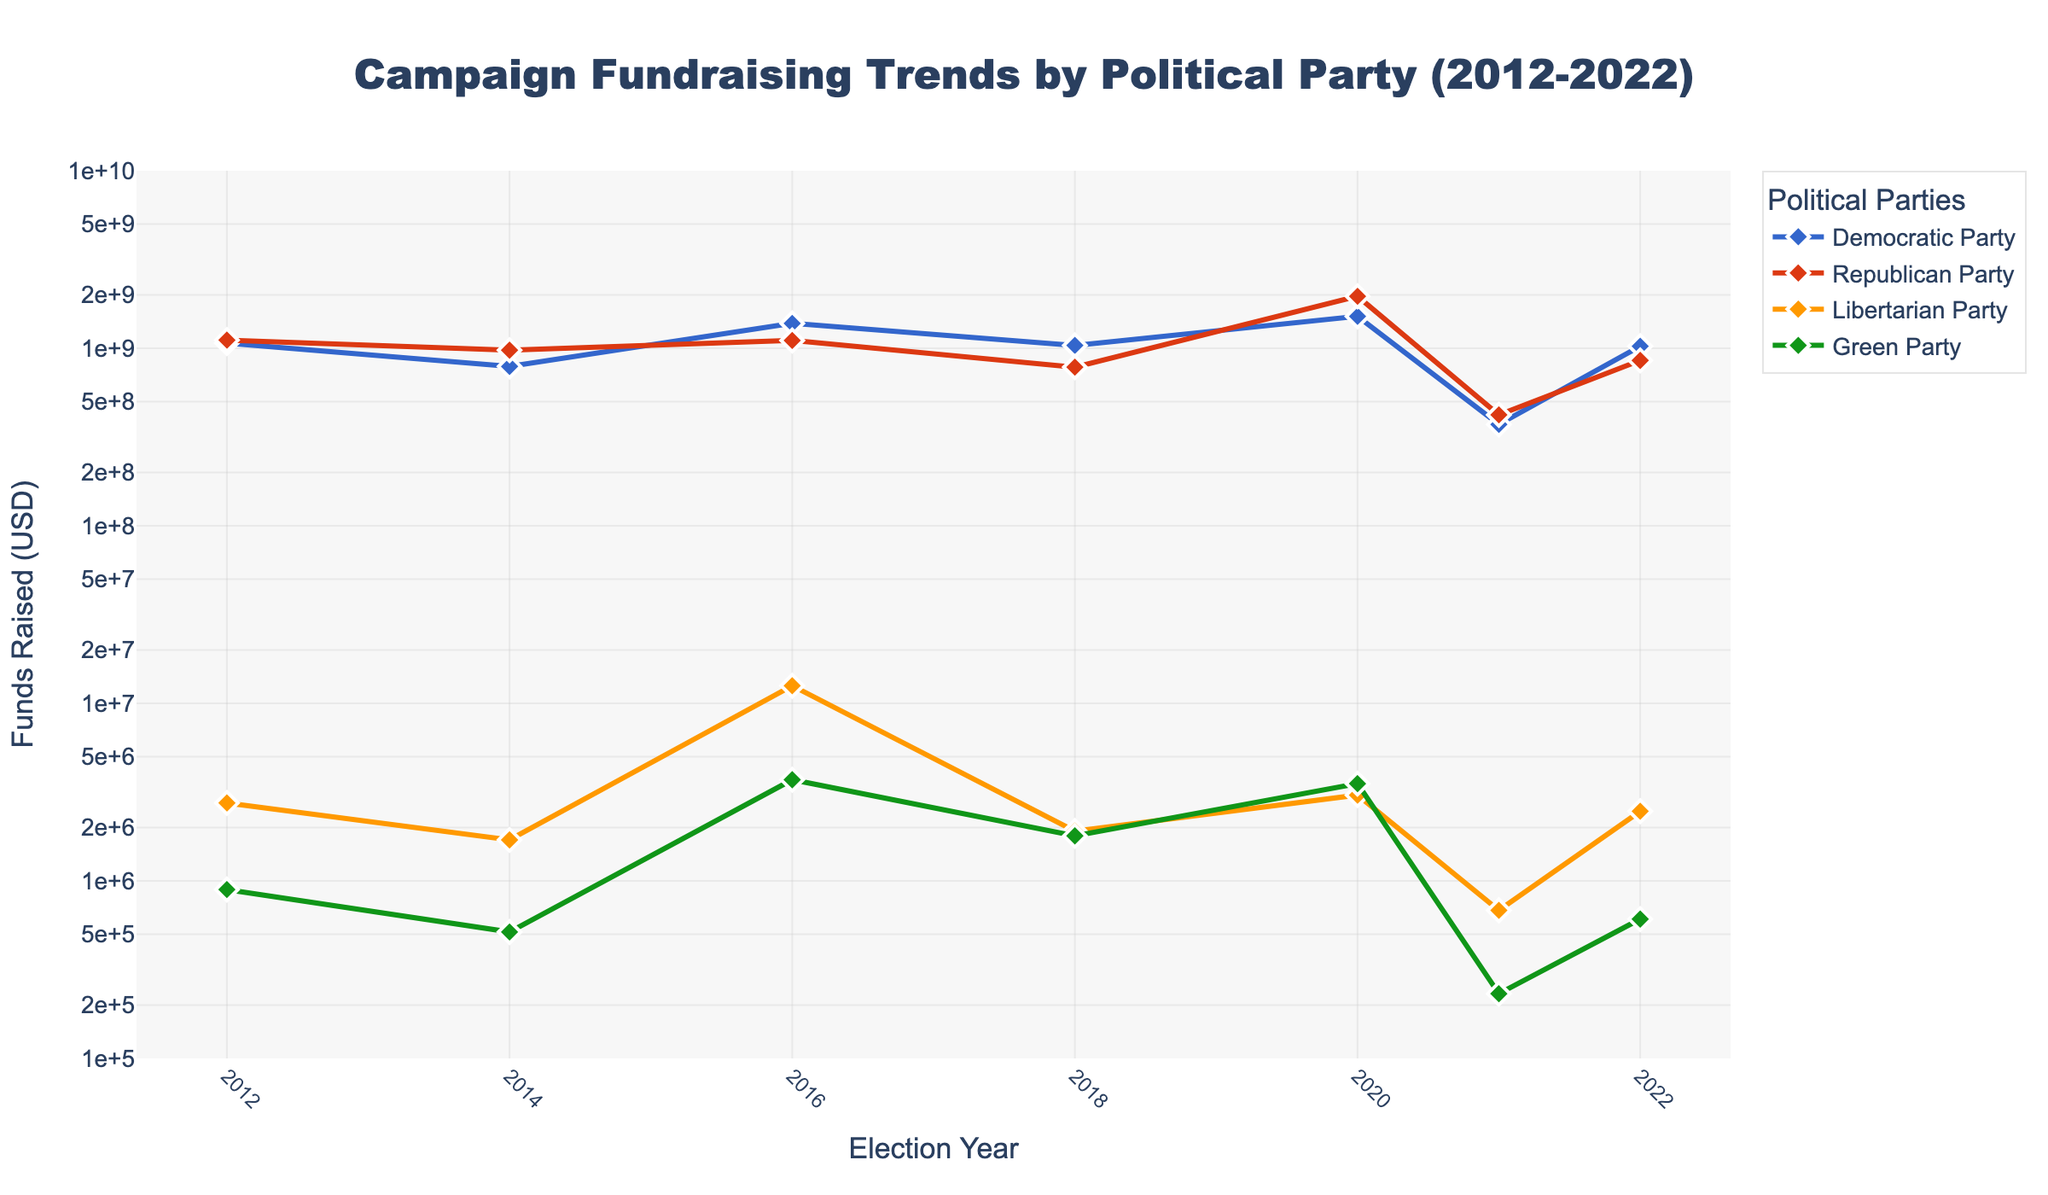What year did the Democratic Party raise the most funds? Look at the green line representing the Democratic Party, and find the peak point on the plot. The peak is in 2020.
Answer: 2020 Which party raised the least amount of funds in 2016? Observe the plot, specifically the data points for 2016. The Green Party has the lowest fundraising amount among the four parties for that year.
Answer: Green Party How much more did the Republican Party raise in 2020 compared to 2022? Identify the Republican Party’s funds for 2020 and 2022 from the plot. In 2020, they raised approximately $1,962,359,061, and in 2022, they raised approximately $853,966,735. The difference is $1,962,359,061 - $853,966,735 = $1,108,392,326.
Answer: $1,108,392,326 In which year did the Libertarian Party see the largest jump in fundraising compared to the previous election cycle? Look at the data points for the Libertarian Party and find the year where the increase between cycles is the largest. The major increase happens between 2014 and 2016, going from around $1,701,403 to $12,557,940.
Answer: 2016 Compare the fundraising trends of the Green Party and Libertarian Party in 2020. Which party raised more funds? Look at the 2020 data points for the Green and Libertarian Parties. The Green Party raised approximately $3,529,935, while the Libertarian Party raised approximately $3,042,062. Green Party raised more.
Answer: Green Party What is the average amount of funds raised by the Republican Party over the last five election cycles? Sum the funds raised by the Republican Party over the five election cycles and divide by 5.  (1111082509 + 975741516 + 1107062809 + 782807378 + 1962359061) / 5 = 1,189,010,254.6
Answer: $1,189,010,254.6 Which party shows the most stable trend in fundraising from 2012 to 2022? Evaluate the consistency of trends (less fluctuation) across all parties from 2012 to 2022. The Democratic Party shows the most stable trend with fewer fluctuations compared to others.
Answer: Democratic Party How did the fundraising of the Democratic Party in 2021 compare to its 2018 fundraising? Identify the data points for the Democratic Party for 2018 and 2021. In 2018, they raised approximately $1,037,561,296, and in 2021, they raised approximately $372,540,931. Therefore, 2018 was higher.
Answer: 2018 was higher Which year saw the highest total combined fundraising by all four parties? Sum the funds raised by all four parties for each year and compare. The highest total combined fundraising: 2012 (1068531133 + 1111082509 + 2748111 + 893658 = 2182368411), 2014 (789954231 + 975741516 + 1701403 + 515661 = 1766726811), 2016 (1380508967 + 1107062809 + 12557940 + 3713170 = 2505340886), 2018 (1037561296 + 782807378 + 1907435 + 1792453 = 1829103562), 2020 (1512676785 + 1962359061 + 3042062 + 3529935 = 3481617843), 2021 (372540931 + 421806950 + 682249 + 231556 = 795261686), 2022 (1026691162 + 853966735 + 2467335 + 609235 = 1881712467). The highest total combined is 2020 with $3,481,617,843.
Answer: 2020 